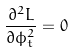Convert formula to latex. <formula><loc_0><loc_0><loc_500><loc_500>\frac { \partial ^ { 2 } L } { \partial \phi _ { t } ^ { 2 } } = 0</formula> 